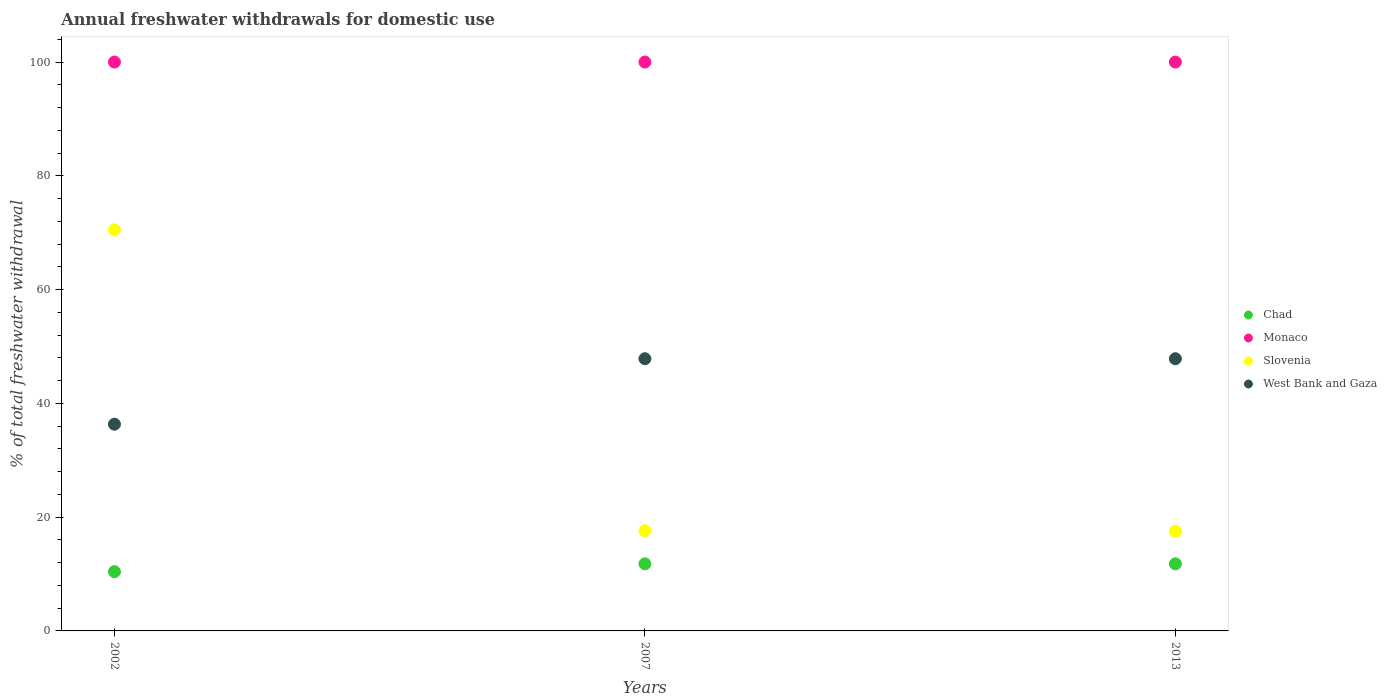What is the total annual withdrawals from freshwater in Chad in 2007?
Keep it short and to the point. 11.79. Across all years, what is the maximum total annual withdrawals from freshwater in Chad?
Keep it short and to the point. 11.79. Across all years, what is the minimum total annual withdrawals from freshwater in Monaco?
Make the answer very short. 100. In which year was the total annual withdrawals from freshwater in Chad maximum?
Your response must be concise. 2007. In which year was the total annual withdrawals from freshwater in West Bank and Gaza minimum?
Your answer should be very brief. 2002. What is the total total annual withdrawals from freshwater in Chad in the graph?
Give a very brief answer. 34. What is the difference between the total annual withdrawals from freshwater in Monaco in 2002 and that in 2007?
Your answer should be very brief. 0. What is the difference between the total annual withdrawals from freshwater in Slovenia in 2013 and the total annual withdrawals from freshwater in Monaco in 2007?
Give a very brief answer. -82.48. What is the average total annual withdrawals from freshwater in West Bank and Gaza per year?
Your answer should be very brief. 44.01. In the year 2007, what is the difference between the total annual withdrawals from freshwater in Chad and total annual withdrawals from freshwater in Monaco?
Offer a very short reply. -88.21. In how many years, is the total annual withdrawals from freshwater in Chad greater than 84 %?
Your answer should be very brief. 0. What is the ratio of the total annual withdrawals from freshwater in Monaco in 2002 to that in 2013?
Offer a terse response. 1. What is the difference between the highest and the second highest total annual withdrawals from freshwater in West Bank and Gaza?
Give a very brief answer. 0. What is the difference between the highest and the lowest total annual withdrawals from freshwater in Slovenia?
Offer a very short reply. 52.99. In how many years, is the total annual withdrawals from freshwater in Slovenia greater than the average total annual withdrawals from freshwater in Slovenia taken over all years?
Keep it short and to the point. 1. Is it the case that in every year, the sum of the total annual withdrawals from freshwater in Chad and total annual withdrawals from freshwater in West Bank and Gaza  is greater than the total annual withdrawals from freshwater in Slovenia?
Give a very brief answer. No. Does the total annual withdrawals from freshwater in West Bank and Gaza monotonically increase over the years?
Give a very brief answer. No. Is the total annual withdrawals from freshwater in Monaco strictly greater than the total annual withdrawals from freshwater in West Bank and Gaza over the years?
Your answer should be very brief. Yes. Is the total annual withdrawals from freshwater in Monaco strictly less than the total annual withdrawals from freshwater in Chad over the years?
Offer a very short reply. No. How many years are there in the graph?
Your answer should be very brief. 3. What is the difference between two consecutive major ticks on the Y-axis?
Ensure brevity in your answer.  20. Does the graph contain grids?
Provide a short and direct response. No. How are the legend labels stacked?
Offer a terse response. Vertical. What is the title of the graph?
Offer a terse response. Annual freshwater withdrawals for domestic use. Does "Belgium" appear as one of the legend labels in the graph?
Make the answer very short. No. What is the label or title of the Y-axis?
Your answer should be compact. % of total freshwater withdrawal. What is the % of total freshwater withdrawal of Chad in 2002?
Give a very brief answer. 10.42. What is the % of total freshwater withdrawal in Slovenia in 2002?
Provide a succinct answer. 70.51. What is the % of total freshwater withdrawal of West Bank and Gaza in 2002?
Provide a succinct answer. 36.34. What is the % of total freshwater withdrawal of Chad in 2007?
Give a very brief answer. 11.79. What is the % of total freshwater withdrawal in Monaco in 2007?
Provide a short and direct response. 100. What is the % of total freshwater withdrawal in West Bank and Gaza in 2007?
Offer a terse response. 47.85. What is the % of total freshwater withdrawal in Chad in 2013?
Offer a very short reply. 11.79. What is the % of total freshwater withdrawal of Slovenia in 2013?
Your answer should be very brief. 17.52. What is the % of total freshwater withdrawal of West Bank and Gaza in 2013?
Your response must be concise. 47.85. Across all years, what is the maximum % of total freshwater withdrawal in Chad?
Keep it short and to the point. 11.79. Across all years, what is the maximum % of total freshwater withdrawal of Monaco?
Provide a short and direct response. 100. Across all years, what is the maximum % of total freshwater withdrawal in Slovenia?
Your answer should be very brief. 70.51. Across all years, what is the maximum % of total freshwater withdrawal of West Bank and Gaza?
Your answer should be compact. 47.85. Across all years, what is the minimum % of total freshwater withdrawal of Chad?
Keep it short and to the point. 10.42. Across all years, what is the minimum % of total freshwater withdrawal in Monaco?
Provide a short and direct response. 100. Across all years, what is the minimum % of total freshwater withdrawal of Slovenia?
Provide a short and direct response. 17.52. Across all years, what is the minimum % of total freshwater withdrawal in West Bank and Gaza?
Provide a succinct answer. 36.34. What is the total % of total freshwater withdrawal of Chad in the graph?
Provide a short and direct response. 34. What is the total % of total freshwater withdrawal in Monaco in the graph?
Your answer should be very brief. 300. What is the total % of total freshwater withdrawal in Slovenia in the graph?
Make the answer very short. 105.63. What is the total % of total freshwater withdrawal in West Bank and Gaza in the graph?
Offer a very short reply. 132.04. What is the difference between the % of total freshwater withdrawal of Chad in 2002 and that in 2007?
Provide a succinct answer. -1.37. What is the difference between the % of total freshwater withdrawal in Slovenia in 2002 and that in 2007?
Your response must be concise. 52.91. What is the difference between the % of total freshwater withdrawal in West Bank and Gaza in 2002 and that in 2007?
Your answer should be compact. -11.51. What is the difference between the % of total freshwater withdrawal in Chad in 2002 and that in 2013?
Keep it short and to the point. -1.37. What is the difference between the % of total freshwater withdrawal of Slovenia in 2002 and that in 2013?
Keep it short and to the point. 52.99. What is the difference between the % of total freshwater withdrawal of West Bank and Gaza in 2002 and that in 2013?
Ensure brevity in your answer.  -11.51. What is the difference between the % of total freshwater withdrawal of West Bank and Gaza in 2007 and that in 2013?
Offer a very short reply. 0. What is the difference between the % of total freshwater withdrawal in Chad in 2002 and the % of total freshwater withdrawal in Monaco in 2007?
Give a very brief answer. -89.58. What is the difference between the % of total freshwater withdrawal of Chad in 2002 and the % of total freshwater withdrawal of Slovenia in 2007?
Provide a succinct answer. -7.18. What is the difference between the % of total freshwater withdrawal of Chad in 2002 and the % of total freshwater withdrawal of West Bank and Gaza in 2007?
Ensure brevity in your answer.  -37.43. What is the difference between the % of total freshwater withdrawal in Monaco in 2002 and the % of total freshwater withdrawal in Slovenia in 2007?
Your answer should be compact. 82.4. What is the difference between the % of total freshwater withdrawal of Monaco in 2002 and the % of total freshwater withdrawal of West Bank and Gaza in 2007?
Give a very brief answer. 52.15. What is the difference between the % of total freshwater withdrawal in Slovenia in 2002 and the % of total freshwater withdrawal in West Bank and Gaza in 2007?
Ensure brevity in your answer.  22.66. What is the difference between the % of total freshwater withdrawal in Chad in 2002 and the % of total freshwater withdrawal in Monaco in 2013?
Give a very brief answer. -89.58. What is the difference between the % of total freshwater withdrawal of Chad in 2002 and the % of total freshwater withdrawal of West Bank and Gaza in 2013?
Offer a very short reply. -37.43. What is the difference between the % of total freshwater withdrawal in Monaco in 2002 and the % of total freshwater withdrawal in Slovenia in 2013?
Provide a succinct answer. 82.48. What is the difference between the % of total freshwater withdrawal of Monaco in 2002 and the % of total freshwater withdrawal of West Bank and Gaza in 2013?
Make the answer very short. 52.15. What is the difference between the % of total freshwater withdrawal in Slovenia in 2002 and the % of total freshwater withdrawal in West Bank and Gaza in 2013?
Your answer should be very brief. 22.66. What is the difference between the % of total freshwater withdrawal of Chad in 2007 and the % of total freshwater withdrawal of Monaco in 2013?
Offer a very short reply. -88.21. What is the difference between the % of total freshwater withdrawal in Chad in 2007 and the % of total freshwater withdrawal in Slovenia in 2013?
Your answer should be compact. -5.73. What is the difference between the % of total freshwater withdrawal in Chad in 2007 and the % of total freshwater withdrawal in West Bank and Gaza in 2013?
Your response must be concise. -36.06. What is the difference between the % of total freshwater withdrawal of Monaco in 2007 and the % of total freshwater withdrawal of Slovenia in 2013?
Make the answer very short. 82.48. What is the difference between the % of total freshwater withdrawal of Monaco in 2007 and the % of total freshwater withdrawal of West Bank and Gaza in 2013?
Your response must be concise. 52.15. What is the difference between the % of total freshwater withdrawal in Slovenia in 2007 and the % of total freshwater withdrawal in West Bank and Gaza in 2013?
Ensure brevity in your answer.  -30.25. What is the average % of total freshwater withdrawal in Chad per year?
Provide a short and direct response. 11.33. What is the average % of total freshwater withdrawal in Slovenia per year?
Offer a very short reply. 35.21. What is the average % of total freshwater withdrawal in West Bank and Gaza per year?
Your answer should be compact. 44.01. In the year 2002, what is the difference between the % of total freshwater withdrawal of Chad and % of total freshwater withdrawal of Monaco?
Your answer should be compact. -89.58. In the year 2002, what is the difference between the % of total freshwater withdrawal in Chad and % of total freshwater withdrawal in Slovenia?
Keep it short and to the point. -60.09. In the year 2002, what is the difference between the % of total freshwater withdrawal in Chad and % of total freshwater withdrawal in West Bank and Gaza?
Make the answer very short. -25.92. In the year 2002, what is the difference between the % of total freshwater withdrawal of Monaco and % of total freshwater withdrawal of Slovenia?
Give a very brief answer. 29.49. In the year 2002, what is the difference between the % of total freshwater withdrawal of Monaco and % of total freshwater withdrawal of West Bank and Gaza?
Make the answer very short. 63.66. In the year 2002, what is the difference between the % of total freshwater withdrawal of Slovenia and % of total freshwater withdrawal of West Bank and Gaza?
Your response must be concise. 34.17. In the year 2007, what is the difference between the % of total freshwater withdrawal of Chad and % of total freshwater withdrawal of Monaco?
Make the answer very short. -88.21. In the year 2007, what is the difference between the % of total freshwater withdrawal of Chad and % of total freshwater withdrawal of Slovenia?
Your response must be concise. -5.81. In the year 2007, what is the difference between the % of total freshwater withdrawal in Chad and % of total freshwater withdrawal in West Bank and Gaza?
Ensure brevity in your answer.  -36.06. In the year 2007, what is the difference between the % of total freshwater withdrawal in Monaco and % of total freshwater withdrawal in Slovenia?
Provide a short and direct response. 82.4. In the year 2007, what is the difference between the % of total freshwater withdrawal of Monaco and % of total freshwater withdrawal of West Bank and Gaza?
Your response must be concise. 52.15. In the year 2007, what is the difference between the % of total freshwater withdrawal in Slovenia and % of total freshwater withdrawal in West Bank and Gaza?
Provide a short and direct response. -30.25. In the year 2013, what is the difference between the % of total freshwater withdrawal in Chad and % of total freshwater withdrawal in Monaco?
Your answer should be compact. -88.21. In the year 2013, what is the difference between the % of total freshwater withdrawal of Chad and % of total freshwater withdrawal of Slovenia?
Provide a succinct answer. -5.73. In the year 2013, what is the difference between the % of total freshwater withdrawal in Chad and % of total freshwater withdrawal in West Bank and Gaza?
Give a very brief answer. -36.06. In the year 2013, what is the difference between the % of total freshwater withdrawal of Monaco and % of total freshwater withdrawal of Slovenia?
Give a very brief answer. 82.48. In the year 2013, what is the difference between the % of total freshwater withdrawal of Monaco and % of total freshwater withdrawal of West Bank and Gaza?
Provide a short and direct response. 52.15. In the year 2013, what is the difference between the % of total freshwater withdrawal of Slovenia and % of total freshwater withdrawal of West Bank and Gaza?
Ensure brevity in your answer.  -30.33. What is the ratio of the % of total freshwater withdrawal of Chad in 2002 to that in 2007?
Provide a succinct answer. 0.88. What is the ratio of the % of total freshwater withdrawal in Monaco in 2002 to that in 2007?
Give a very brief answer. 1. What is the ratio of the % of total freshwater withdrawal in Slovenia in 2002 to that in 2007?
Make the answer very short. 4.01. What is the ratio of the % of total freshwater withdrawal in West Bank and Gaza in 2002 to that in 2007?
Keep it short and to the point. 0.76. What is the ratio of the % of total freshwater withdrawal in Chad in 2002 to that in 2013?
Keep it short and to the point. 0.88. What is the ratio of the % of total freshwater withdrawal in Monaco in 2002 to that in 2013?
Provide a short and direct response. 1. What is the ratio of the % of total freshwater withdrawal in Slovenia in 2002 to that in 2013?
Your response must be concise. 4.02. What is the ratio of the % of total freshwater withdrawal of West Bank and Gaza in 2002 to that in 2013?
Provide a succinct answer. 0.76. What is the ratio of the % of total freshwater withdrawal of Chad in 2007 to that in 2013?
Your answer should be very brief. 1. What is the ratio of the % of total freshwater withdrawal of Slovenia in 2007 to that in 2013?
Your answer should be very brief. 1. What is the difference between the highest and the second highest % of total freshwater withdrawal of Chad?
Your answer should be very brief. 0. What is the difference between the highest and the second highest % of total freshwater withdrawal in Slovenia?
Your response must be concise. 52.91. What is the difference between the highest and the lowest % of total freshwater withdrawal of Chad?
Keep it short and to the point. 1.37. What is the difference between the highest and the lowest % of total freshwater withdrawal of Monaco?
Your response must be concise. 0. What is the difference between the highest and the lowest % of total freshwater withdrawal in Slovenia?
Your response must be concise. 52.99. What is the difference between the highest and the lowest % of total freshwater withdrawal in West Bank and Gaza?
Keep it short and to the point. 11.51. 